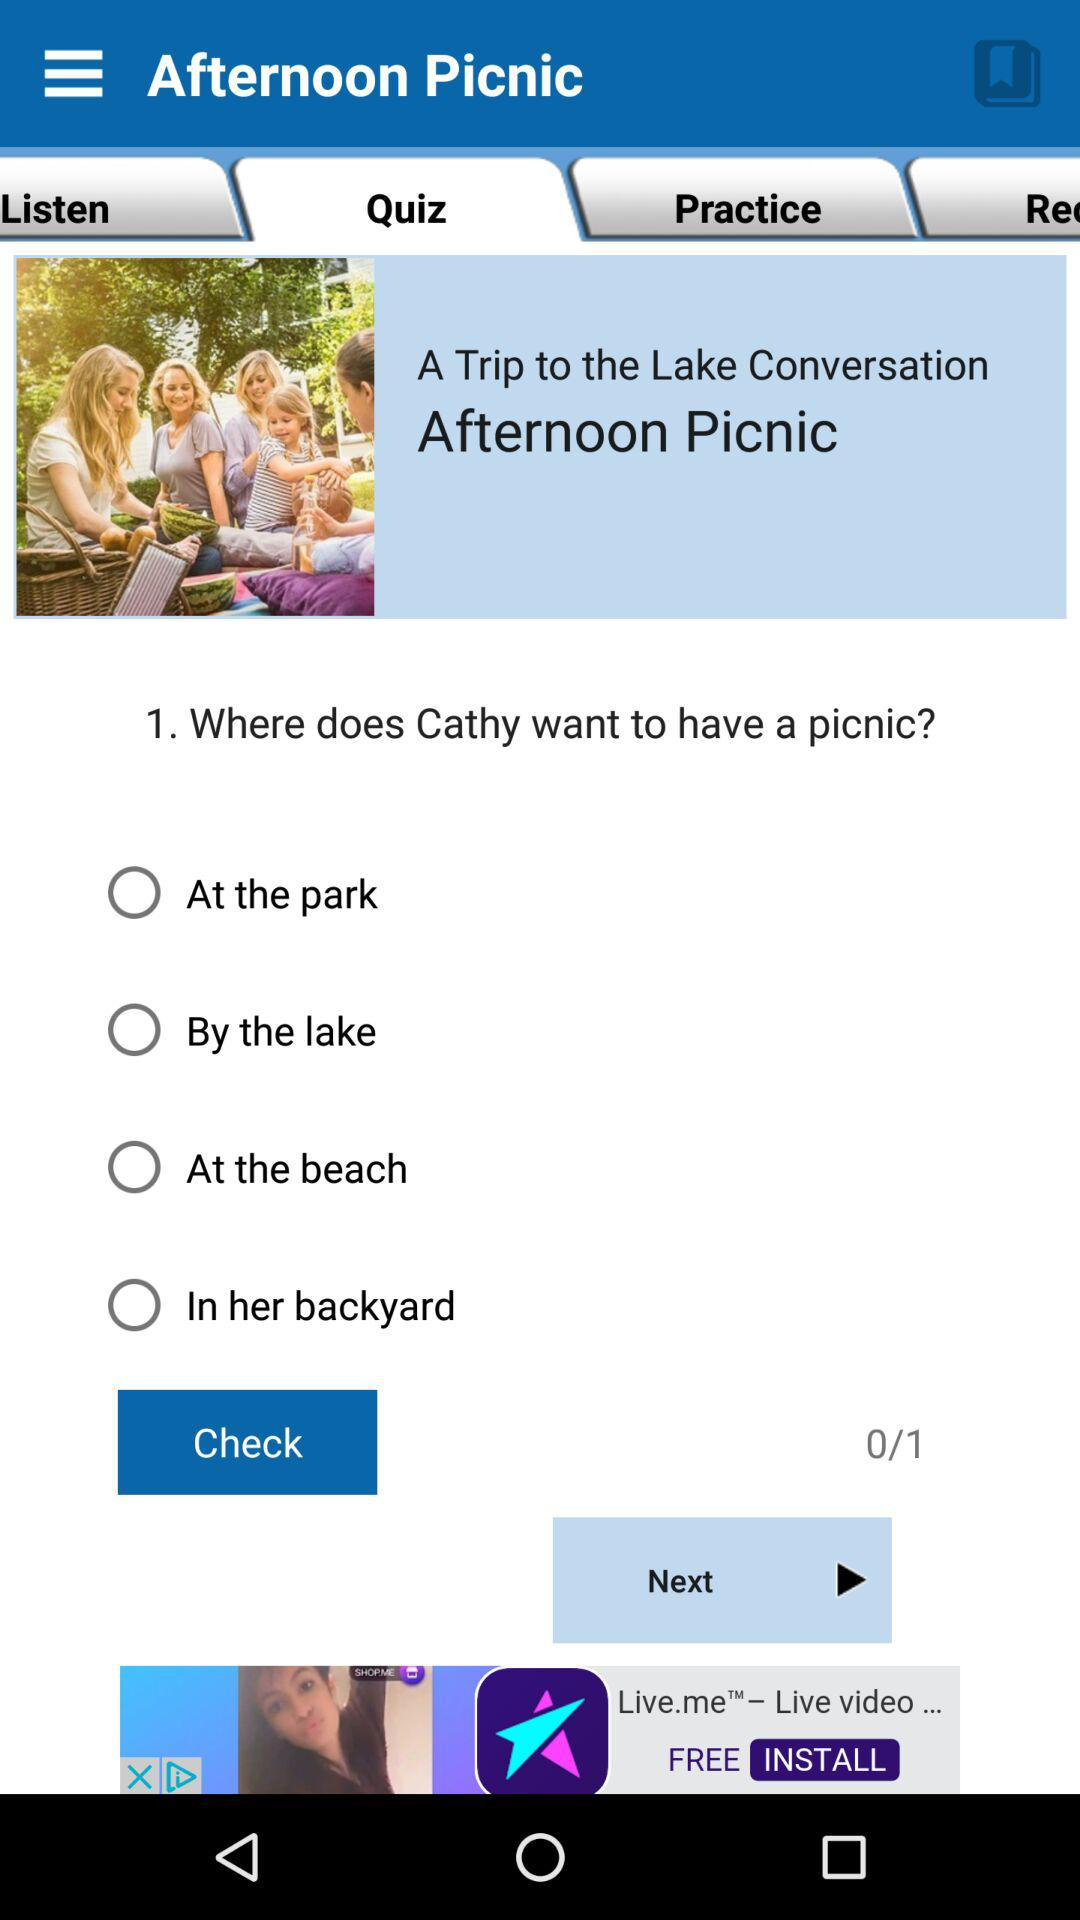How many options are there to choose where Cathy wants to have a picnic?
Answer the question using a single word or phrase. 4 